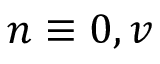Convert formula to latex. <formula><loc_0><loc_0><loc_500><loc_500>n \equiv 0 , v</formula> 